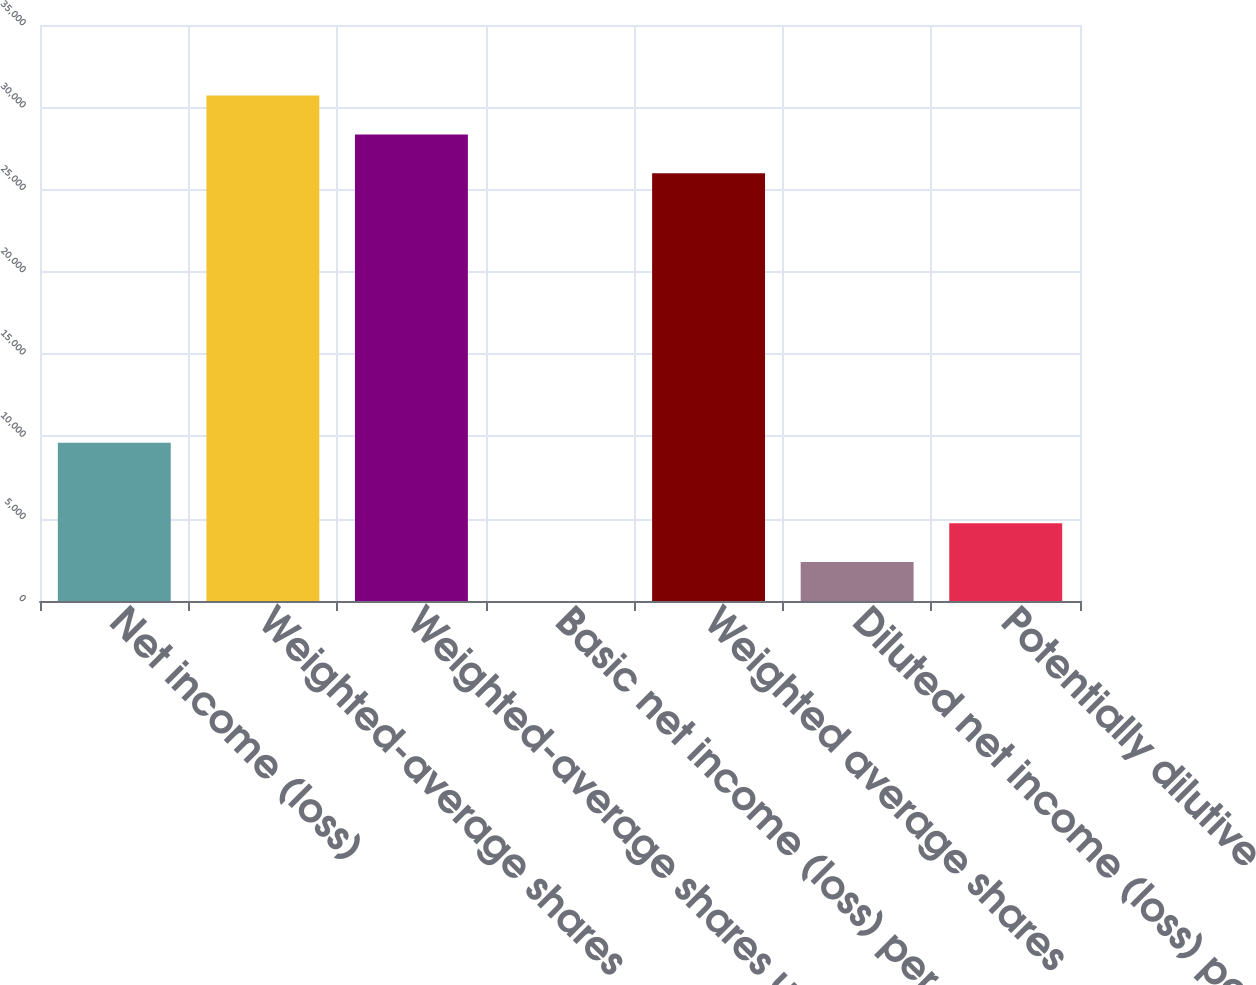Convert chart to OTSL. <chart><loc_0><loc_0><loc_500><loc_500><bar_chart><fcel>Net income (loss)<fcel>Weighted-average shares<fcel>Weighted-average shares used<fcel>Basic net income (loss) per<fcel>Weighted average shares<fcel>Diluted net income (loss) per<fcel>Potentially dilutive<nl><fcel>9623<fcel>30714.9<fcel>28351.9<fcel>0.41<fcel>25989<fcel>2363.37<fcel>4726.33<nl></chart> 